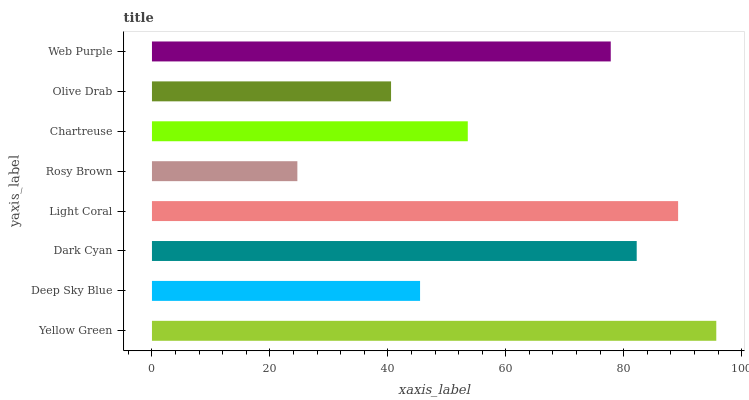Is Rosy Brown the minimum?
Answer yes or no. Yes. Is Yellow Green the maximum?
Answer yes or no. Yes. Is Deep Sky Blue the minimum?
Answer yes or no. No. Is Deep Sky Blue the maximum?
Answer yes or no. No. Is Yellow Green greater than Deep Sky Blue?
Answer yes or no. Yes. Is Deep Sky Blue less than Yellow Green?
Answer yes or no. Yes. Is Deep Sky Blue greater than Yellow Green?
Answer yes or no. No. Is Yellow Green less than Deep Sky Blue?
Answer yes or no. No. Is Web Purple the high median?
Answer yes or no. Yes. Is Chartreuse the low median?
Answer yes or no. Yes. Is Rosy Brown the high median?
Answer yes or no. No. Is Rosy Brown the low median?
Answer yes or no. No. 